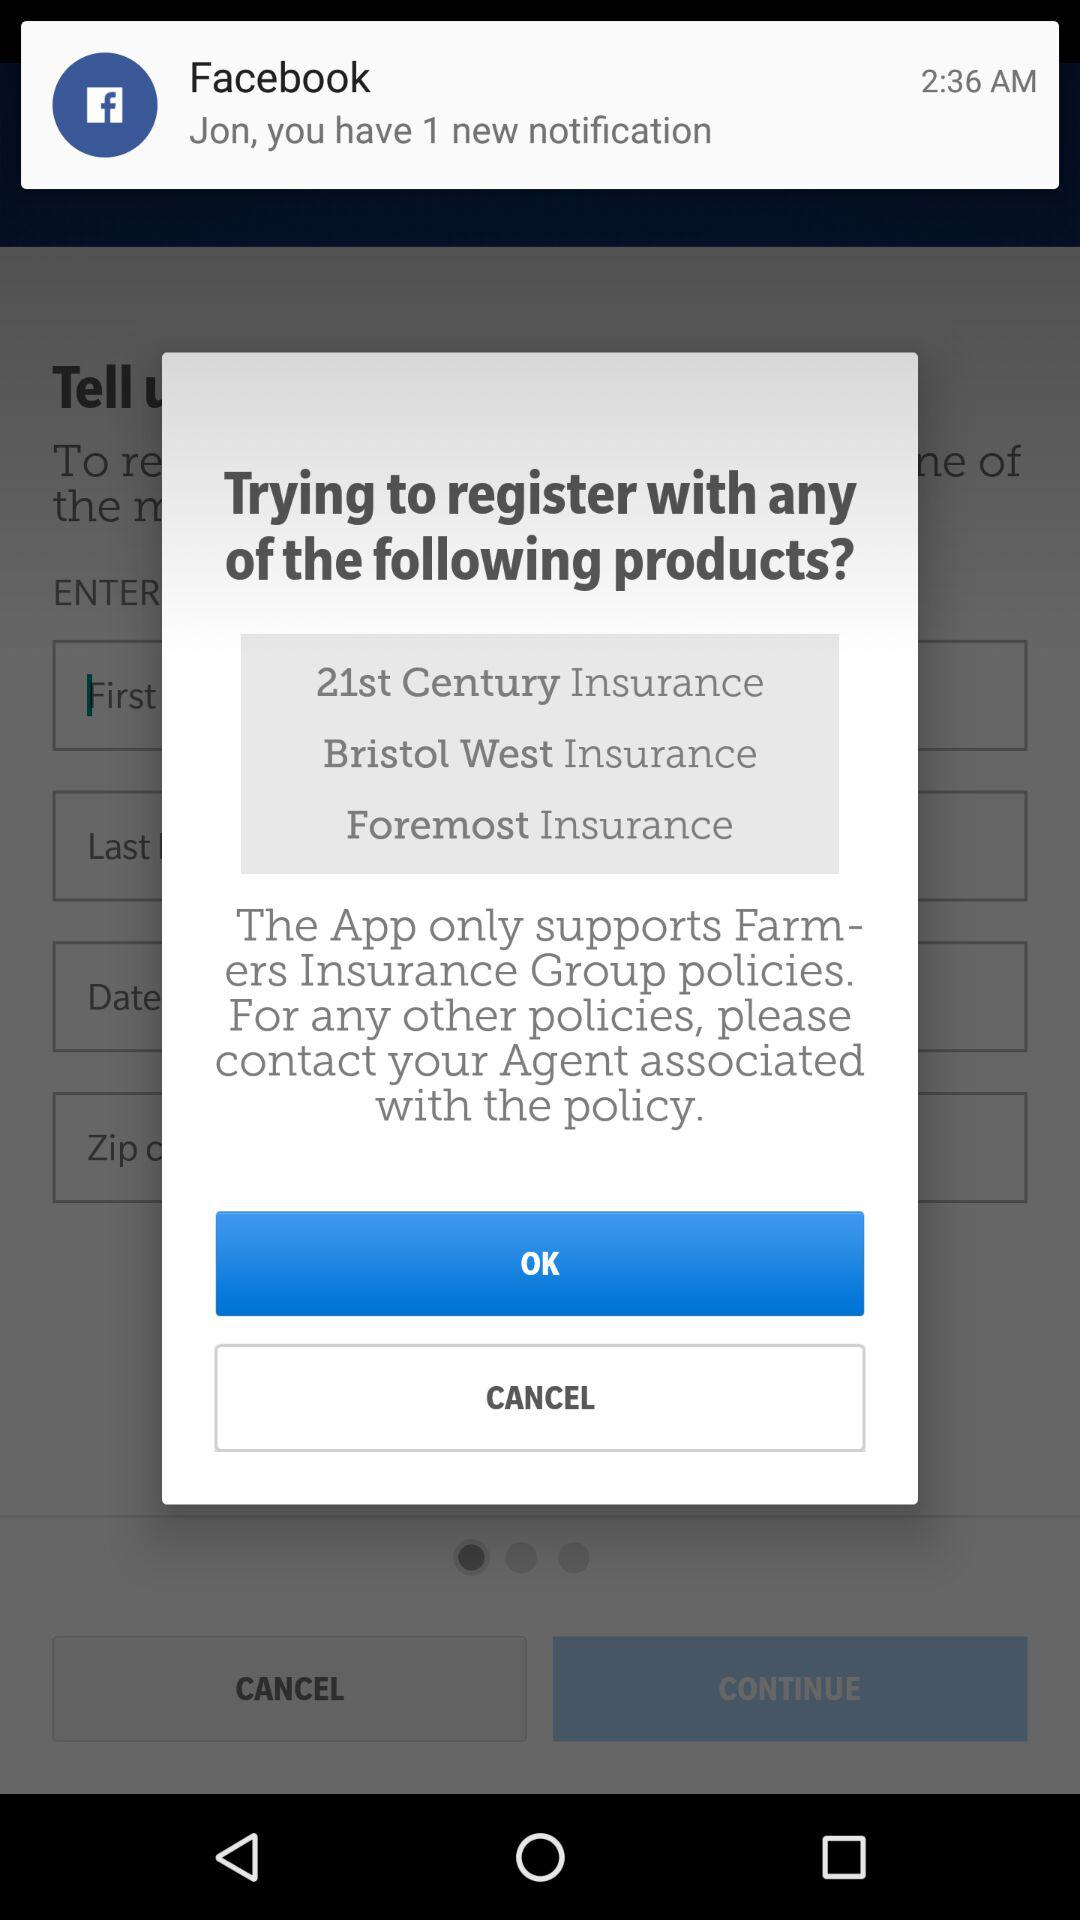What is the number of notifications? The number of notifications is 1. 